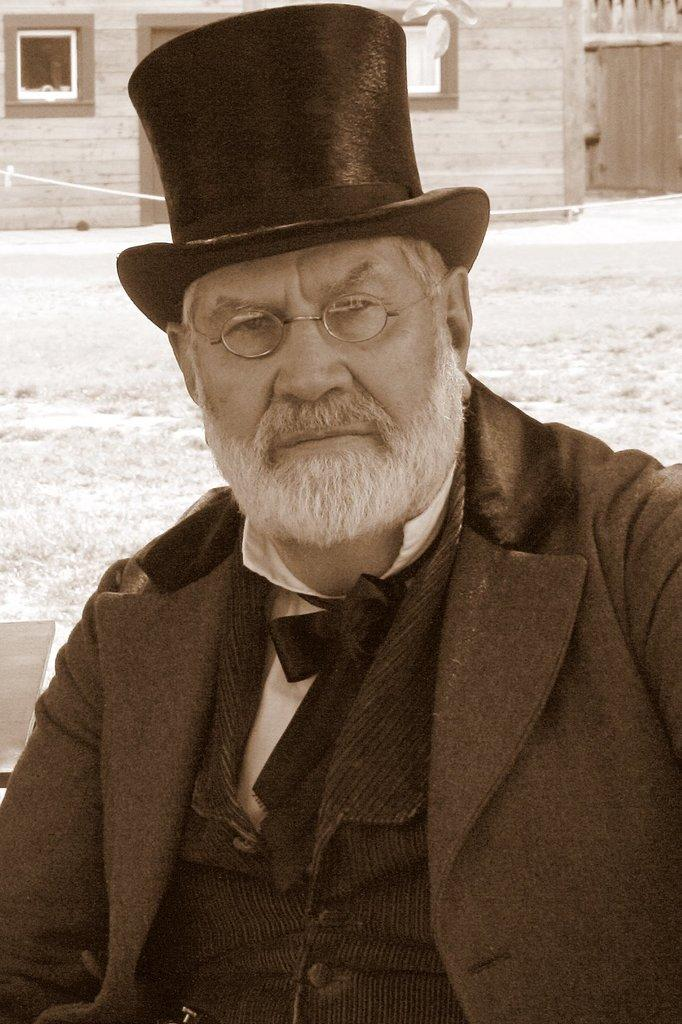What is the main subject of the image? The main subject of the image is a man. Can you describe the man's attire? The man is wearing spectacles, a cap, a blazer, and a bow tie. What can be seen in the background of the image? There is grass, a house with windows, and a wall visible in the image. What disease is the man suffering from in the image? There is no indication in the image that the man is suffering from any disease. What year was the image taken? The year the image was taken is not mentioned in the facts provided. 